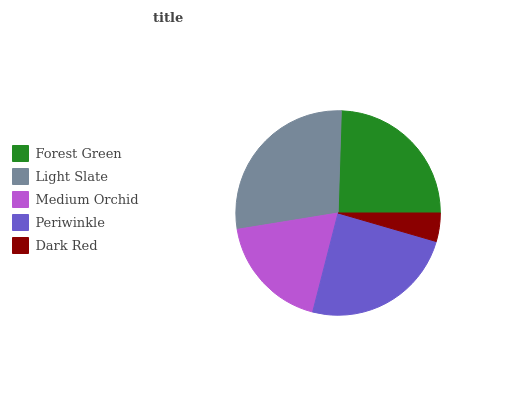Is Dark Red the minimum?
Answer yes or no. Yes. Is Light Slate the maximum?
Answer yes or no. Yes. Is Medium Orchid the minimum?
Answer yes or no. No. Is Medium Orchid the maximum?
Answer yes or no. No. Is Light Slate greater than Medium Orchid?
Answer yes or no. Yes. Is Medium Orchid less than Light Slate?
Answer yes or no. Yes. Is Medium Orchid greater than Light Slate?
Answer yes or no. No. Is Light Slate less than Medium Orchid?
Answer yes or no. No. Is Periwinkle the high median?
Answer yes or no. Yes. Is Periwinkle the low median?
Answer yes or no. Yes. Is Forest Green the high median?
Answer yes or no. No. Is Light Slate the low median?
Answer yes or no. No. 